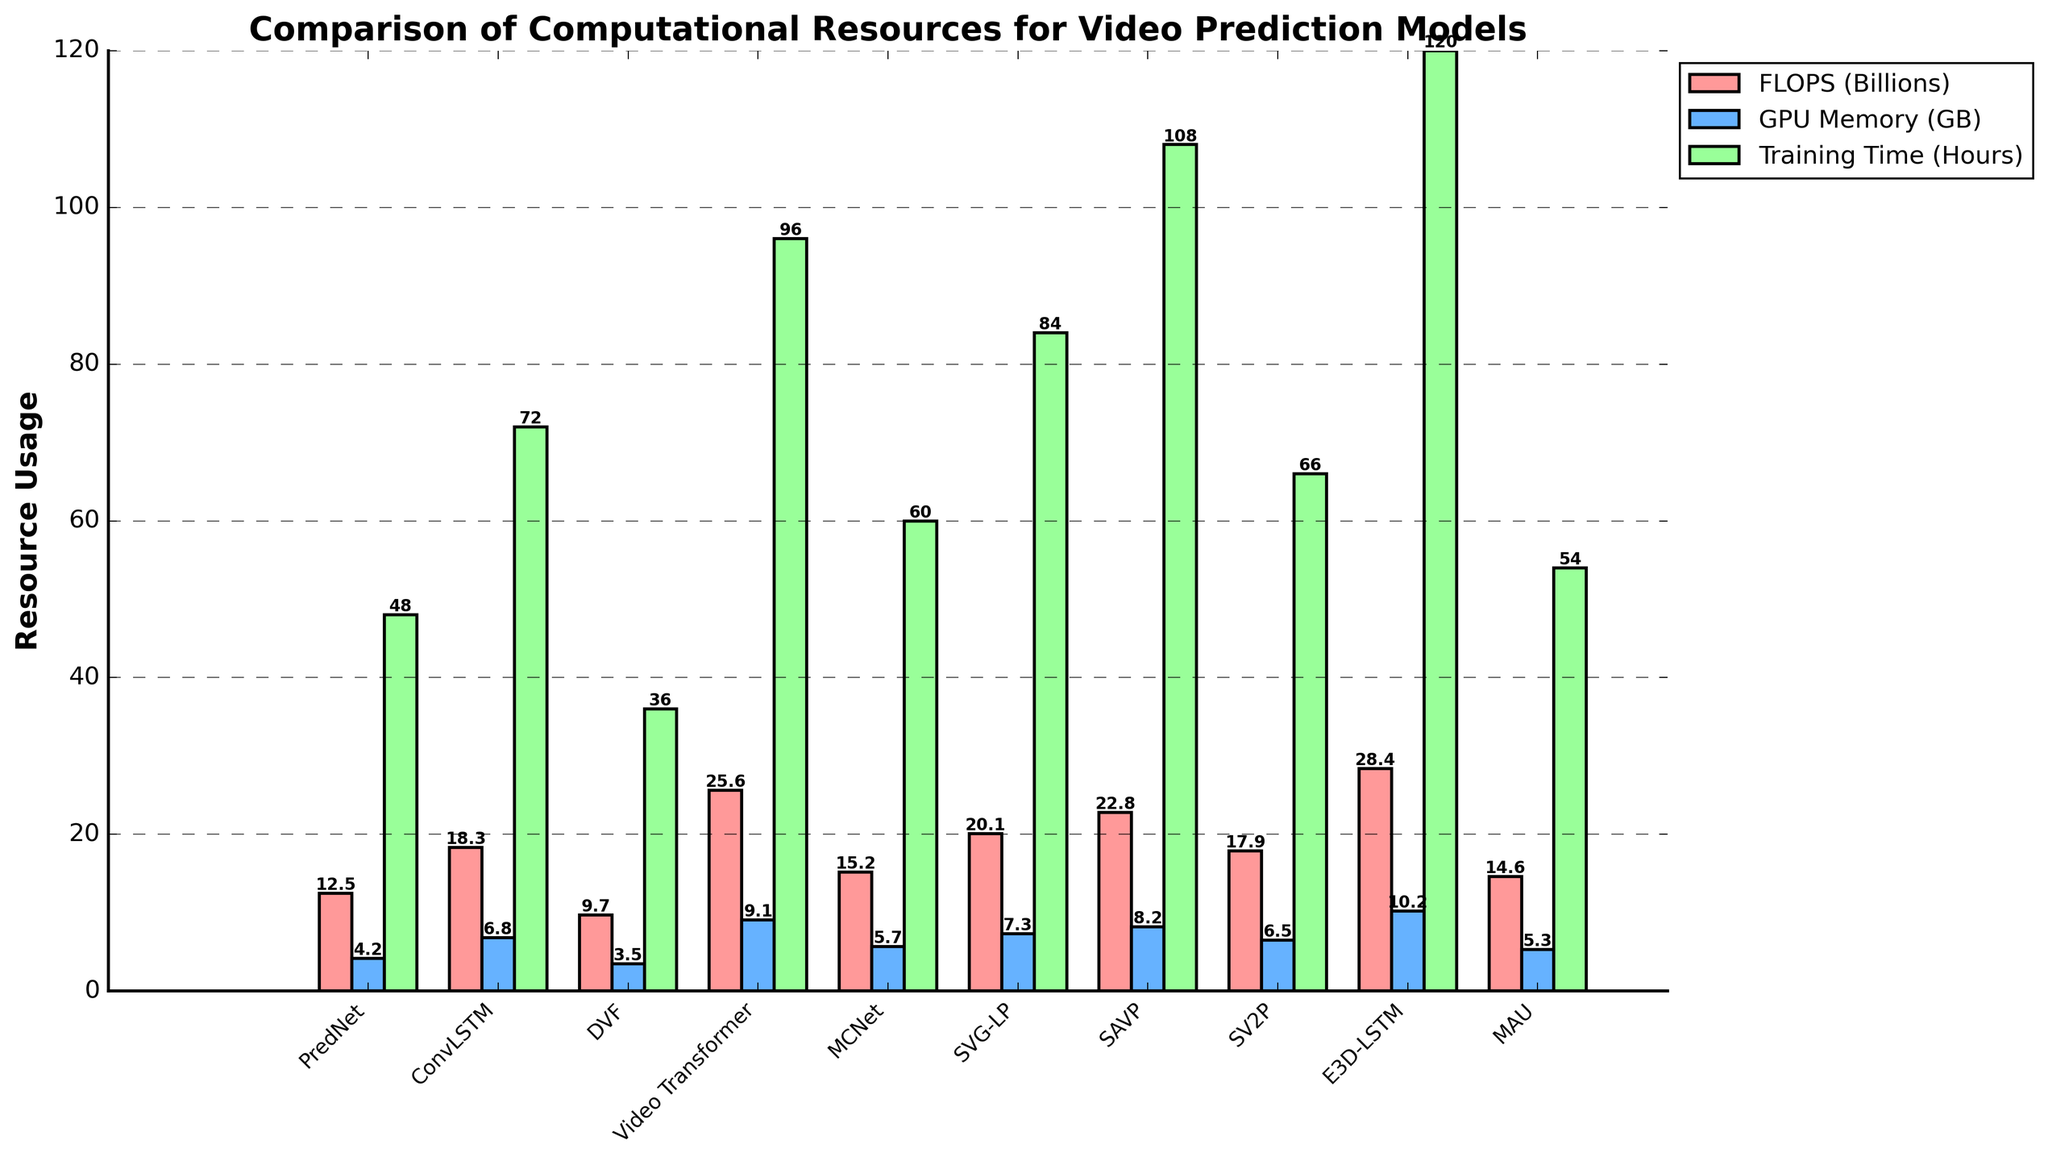What model has the highest FLOPS (Billions)? Examining the height of the red bars in the figure, the 'E3D-LSTM' model has the tallest bar, indicating the highest FLOPS.
Answer: E3D-LSTM Which model requires the least GPU Memory (GB)? By looking at the height of the blue bars representing GPU memory usage, the 'DVF' model has the shortest bar.
Answer: DVF How much longer is the training time for the Video Transformer compared to MCNet? The green bar height for Video Transformer (96 hours) minus the green bar height for MCNet (60 hours) gives the difference. 96 - 60 = 36.
Answer: 36 hours What is the sum of GPU Memory (GB) required for ConvLSTM and MAU? Add the heights of the blue bars for ConvLSTM (6.8 GB) and MAU (5.3 GB). 6.8 + 5.3 = 12.1
Answer: 12.1 GB Which model has both higher FLOPS (Billions) and Training Time (Hours) than PredNet? Comparing the heights of the red and green bars, the 'Video Transformer', 'SVG-LP', 'SAVP', and 'E3D-LSTM' models have both higher FLOPS and Training Time than PredNet.
Answer: Video Transformer, SVG-LP, SAVP, E3D-LSTM What is the average FLOPS (Billions) of all the models? Sum all the heights of the red bars representing FLOPS and divide by the number of models (10). (12.5 + 18.3 + 9.7 + 25.6 + 15.2 + 20.1 + 22.8 + 17.9 + 28.4 + 14.6) / 10 = 185.1 / 10 = 18.51
Answer: 18.51 Which model has the lowest Training Time (Hours) and what is its FLOPS (Billions)? The shortest green bar for Training Time is 'DVF' with 36 hours, and its red bar for FLOPS shows 9.7 Billion.
Answer: DVF, 9.7 Is there any model with exactly equal GPU Memory (GB) and FLOPS (Billions)? Observing the bar heights for each model, no model has equal heights for both GPU Memory and FLOPS red and blue bars.
Answer: No What's the difference in FLOPS between the highest and lowest models? The tallest red bar for FLOPS is 'E3D-LSTM' (28.4 Billions) and the shortest is 'DVF' (9.7 Billions). Subtract the lower value from the higher. 28.4 - 9.7 = 18.7
Answer: 18.7 Billion FLOPS 